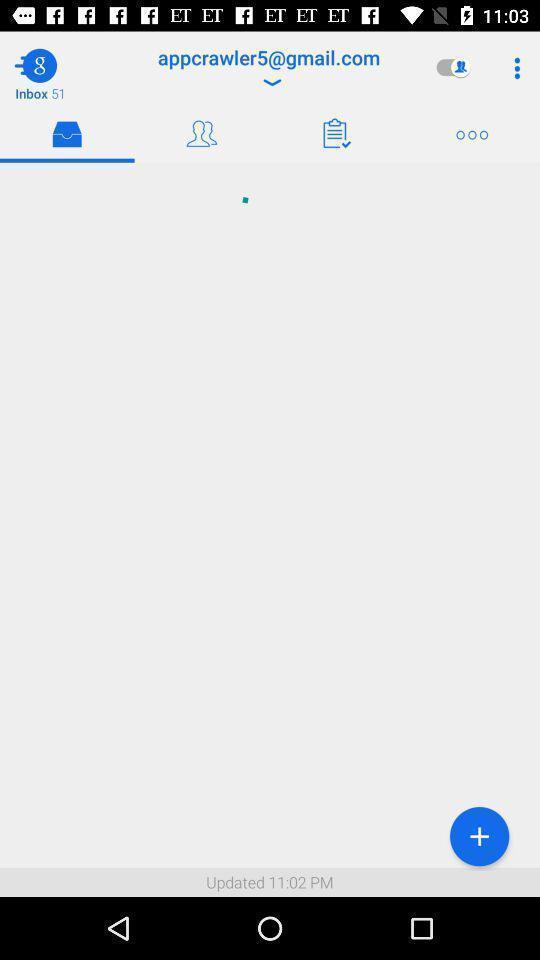Give me a narrative description of this picture. Window displaying an email app. 